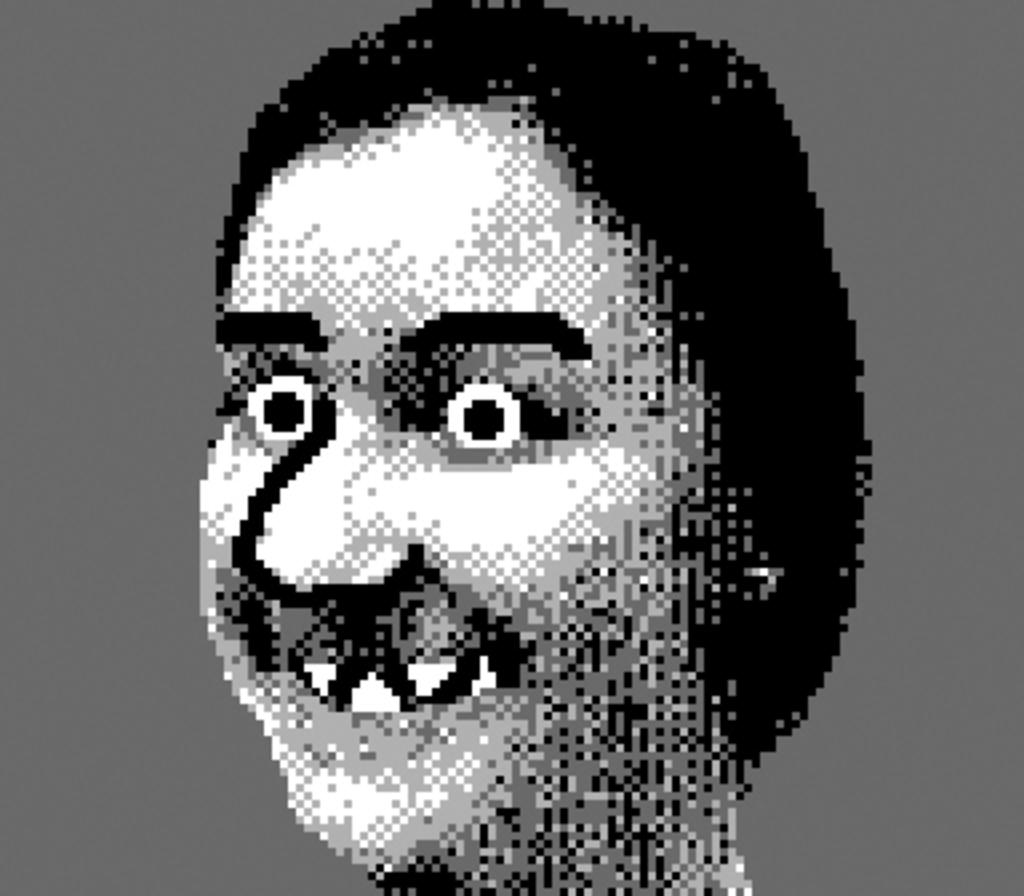What is the main subject of the image? There is a picture of a woman in the image. What can be said about the color scheme of the image? The picture is in black and white color. What type of brain activity is depicted in the image? There is no depiction of brain activity in the image, as it features a picture of a woman in black and white. What time of day is the volleyball game taking place in the image? There is no volleyball game present in the image, so it is not possible to determine the time of day. 